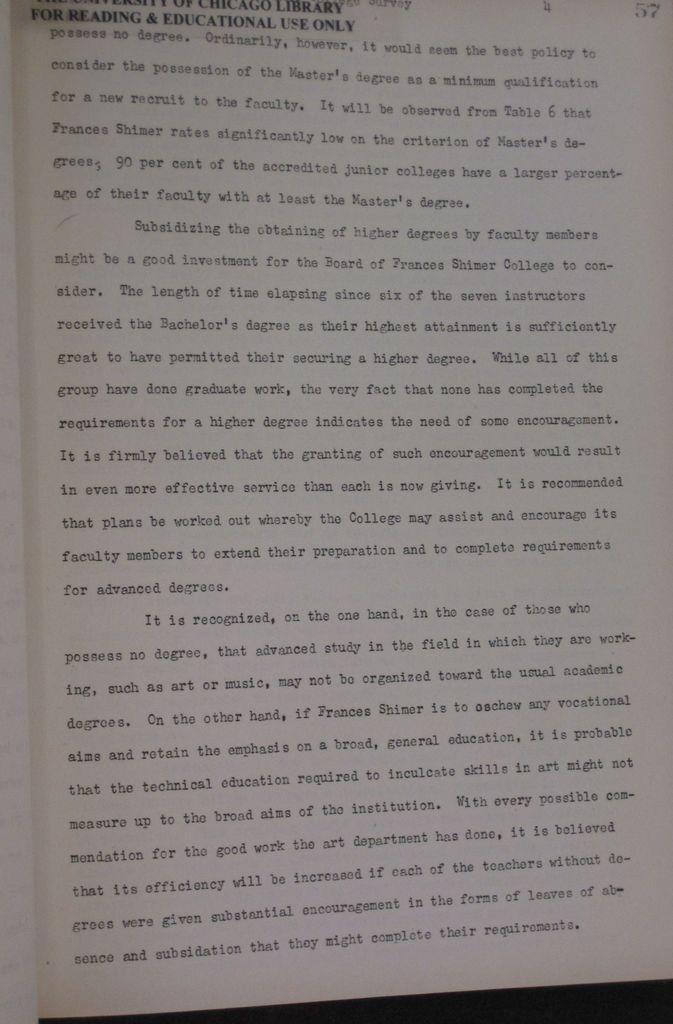<image>
Write a terse but informative summary of the picture. a page of words with part of the title saying 'for reading & educational use only' 